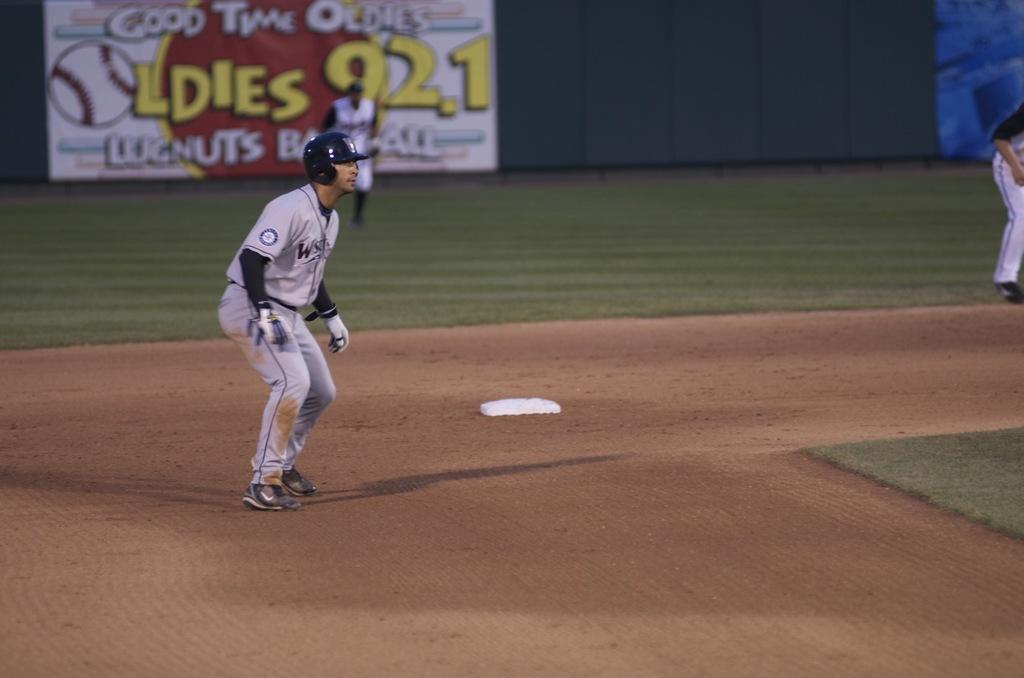<image>
Share a concise interpretation of the image provided. The radio station in the background is 92.1 